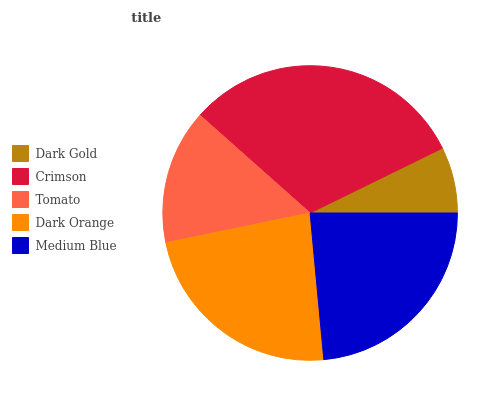Is Dark Gold the minimum?
Answer yes or no. Yes. Is Crimson the maximum?
Answer yes or no. Yes. Is Tomato the minimum?
Answer yes or no. No. Is Tomato the maximum?
Answer yes or no. No. Is Crimson greater than Tomato?
Answer yes or no. Yes. Is Tomato less than Crimson?
Answer yes or no. Yes. Is Tomato greater than Crimson?
Answer yes or no. No. Is Crimson less than Tomato?
Answer yes or no. No. Is Dark Orange the high median?
Answer yes or no. Yes. Is Dark Orange the low median?
Answer yes or no. Yes. Is Dark Gold the high median?
Answer yes or no. No. Is Dark Gold the low median?
Answer yes or no. No. 